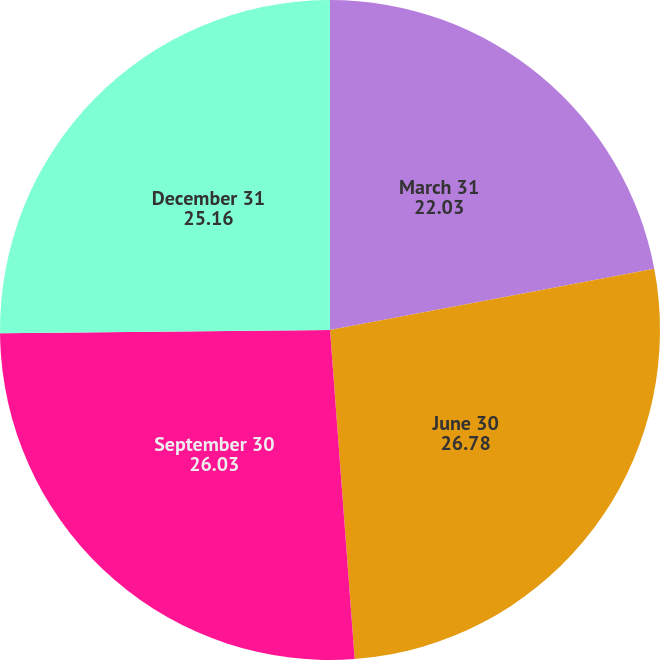Convert chart to OTSL. <chart><loc_0><loc_0><loc_500><loc_500><pie_chart><fcel>March 31<fcel>June 30<fcel>September 30<fcel>December 31<nl><fcel>22.03%<fcel>26.78%<fcel>26.03%<fcel>25.16%<nl></chart> 